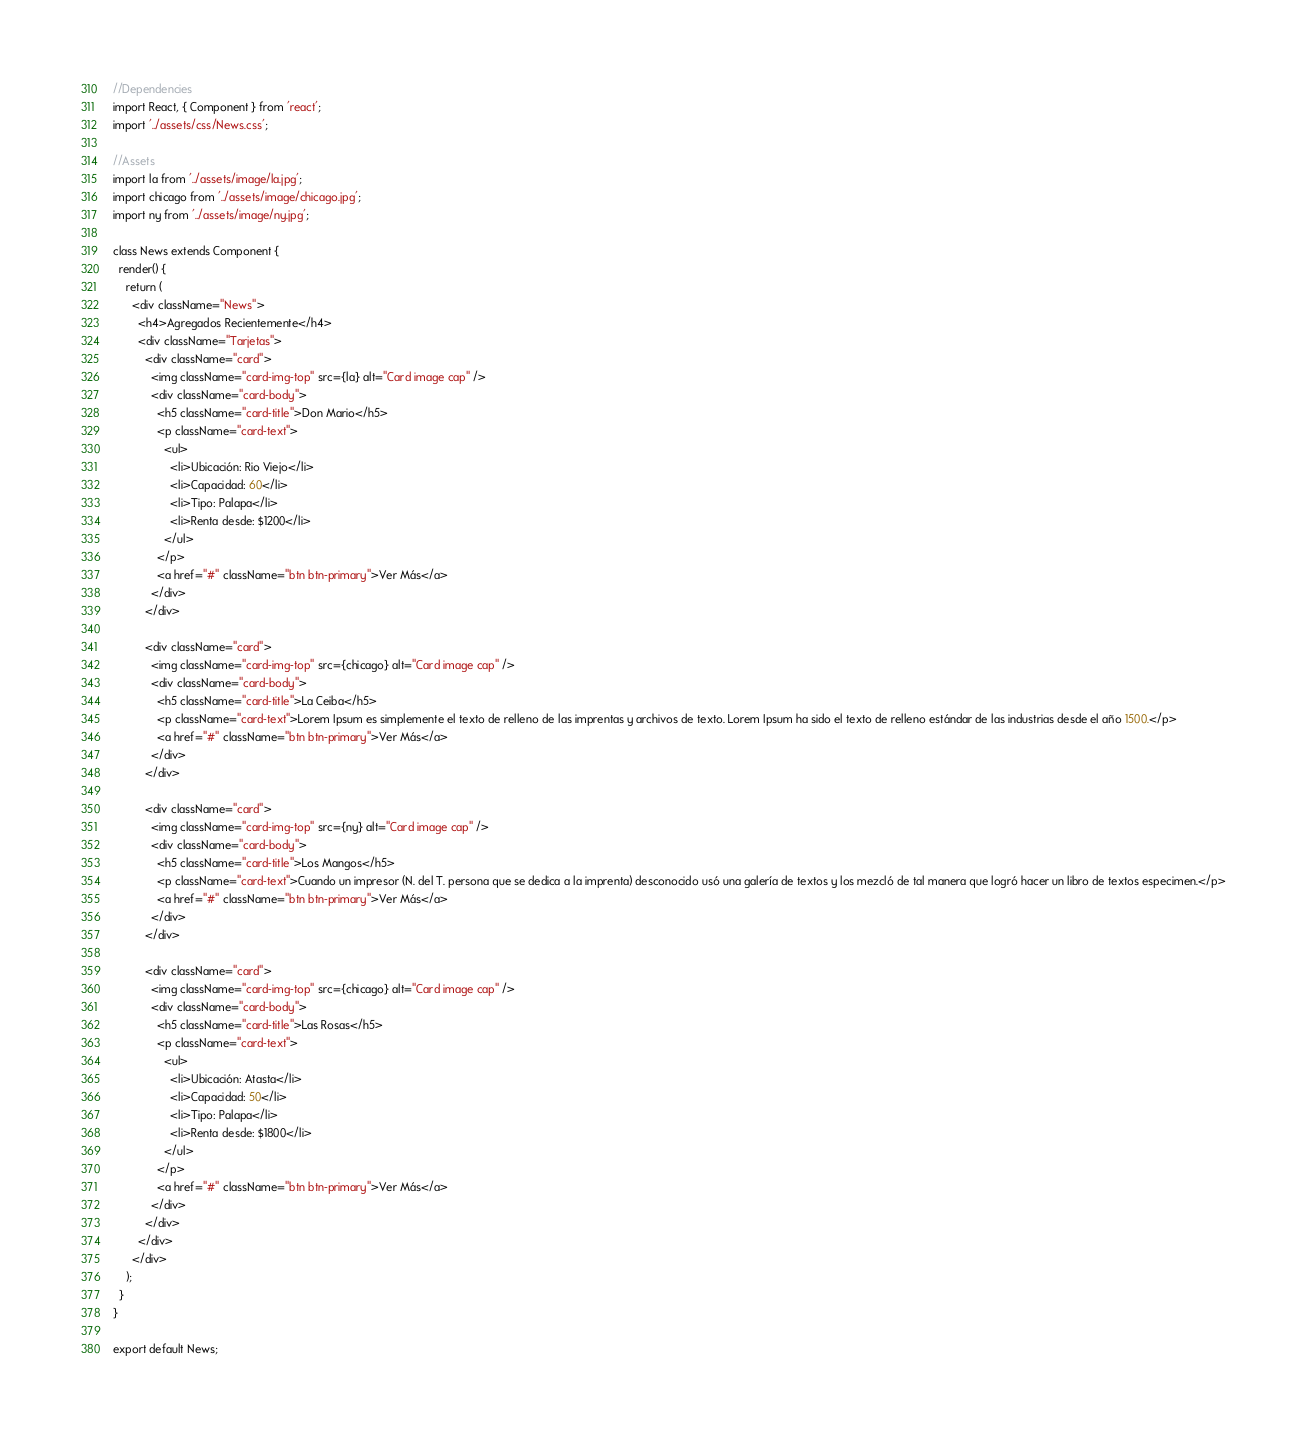Convert code to text. <code><loc_0><loc_0><loc_500><loc_500><_JavaScript_>//Dependencies
import React, { Component } from 'react';
import '../assets/css/News.css';

//Assets
import la from '../assets/image/la.jpg';
import chicago from '../assets/image/chicago.jpg';
import ny from '../assets/image/ny.jpg';

class News extends Component {
  render() {
    return (
      <div className="News">
        <h4>Agregados Recientemente</h4>
        <div className="Tarjetas">
          <div className="card">
            <img className="card-img-top" src={la} alt="Card image cap" />
            <div className="card-body">
              <h5 className="card-title">Don Mario</h5>
              <p className="card-text">
                <ul>
                  <li>Ubicación: Rio Viejo</li>
                  <li>Capacidad: 60</li>
                  <li>Tipo: Palapa</li>
                  <li>Renta desde: $1200</li>
                </ul>
              </p>
              <a href="#" className="btn btn-primary">Ver Más</a>
            </div>
          </div>

          <div className="card">
            <img className="card-img-top" src={chicago} alt="Card image cap" />
            <div className="card-body">
              <h5 className="card-title">La Ceiba</h5>
              <p className="card-text">Lorem Ipsum es simplemente el texto de relleno de las imprentas y archivos de texto. Lorem Ipsum ha sido el texto de relleno estándar de las industrias desde el año 1500.</p>
              <a href="#" className="btn btn-primary">Ver Más</a>
            </div>
          </div>

          <div className="card">
            <img className="card-img-top" src={ny} alt="Card image cap" />
            <div className="card-body">
              <h5 className="card-title">Los Mangos</h5>
              <p className="card-text">Cuando un impresor (N. del T. persona que se dedica a la imprenta) desconocido usó una galería de textos y los mezcló de tal manera que logró hacer un libro de textos especimen.</p>
              <a href="#" className="btn btn-primary">Ver Más</a>
            </div>
          </div>

          <div className="card">
            <img className="card-img-top" src={chicago} alt="Card image cap" />
            <div className="card-body">
              <h5 className="card-title">Las Rosas</h5>
              <p className="card-text">
                <ul>
                  <li>Ubicación: Atasta</li>
                  <li>Capacidad: 50</li>
                  <li>Tipo: Palapa</li>
                  <li>Renta desde: $1800</li>
                </ul>
              </p>
              <a href="#" className="btn btn-primary">Ver Más</a>
            </div>
          </div>
        </div>
      </div>
    );
  }
}

export default News;</code> 